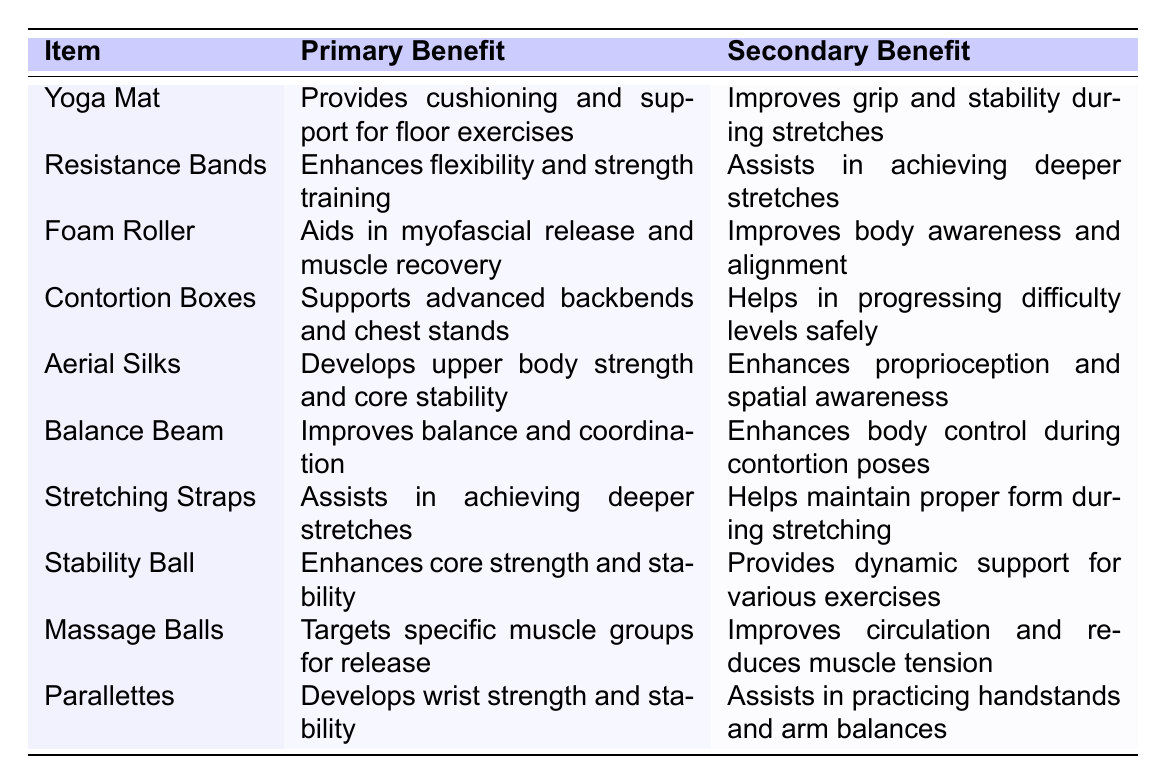What is the primary benefit of using a Yoga Mat? The table lists "Provides cushioning and support for floor exercises" as the primary benefit associated with the Yoga Mat.
Answer: Provides cushioning and support for floor exercises Which prop is known for assisting in achieving deeper stretches? The table shows that both Resistance Bands and Stretching Straps are associated with assisting in achieving deeper stretches.
Answer: Resistance Bands and Stretching Straps What item aids in myofascial release and muscle recovery? According to the table, the Foam Roller is specified as aiding in myofascial release and muscle recovery.
Answer: Foam Roller Does the Balance Beam have any secondary benefits related to body control? The table states that the Balance Beam enhances body control during contortion poses, indicating that it does have a secondary benefit related to body control.
Answer: Yes Which item develops upper body strength and core stability? The table indicates that Aerial Silks are used to develop upper body strength and core stability.
Answer: Aerial Silks How many props are listed that assist in achieving deeper stretches? The table lists two items (Resistance Bands and Stretching Straps) that are mentioned to assist in achieving deeper stretches.
Answer: Two What is the primary benefit of using a Stability Ball? From the table, the primary benefit of using a Stability Ball is enhancing core strength and stability.
Answer: Enhances core strength and stability Which item supports advanced backbends and chest stands? The table identifies Contortion Boxes as the item that supports advanced backbends and chest stands.
Answer: Contortion Boxes What are the secondary benefits of Massage Balls? The table shows that the secondary benefits of Massage Balls are improving circulation and reducing muscle tension.
Answer: Improves circulation and reduces muscle tension If you wanted to improve your grip and stability during stretches, which prop should you use? The table specifies that a Yoga Mat improves grip and stability during stretches, making it the recommended choice.
Answer: Yoga Mat Is there an item that combines the enhancement of flexibility and strength training? Yes, the table assesses Resistance Bands as enhancing both flexibility and strength training.
Answer: Yes Which two pieces of equipment enhance proprioception and spatial awareness? Aerial Silks are noted in the table as enhancing proprioception and spatial awareness.
Answer: Aerial Silks 